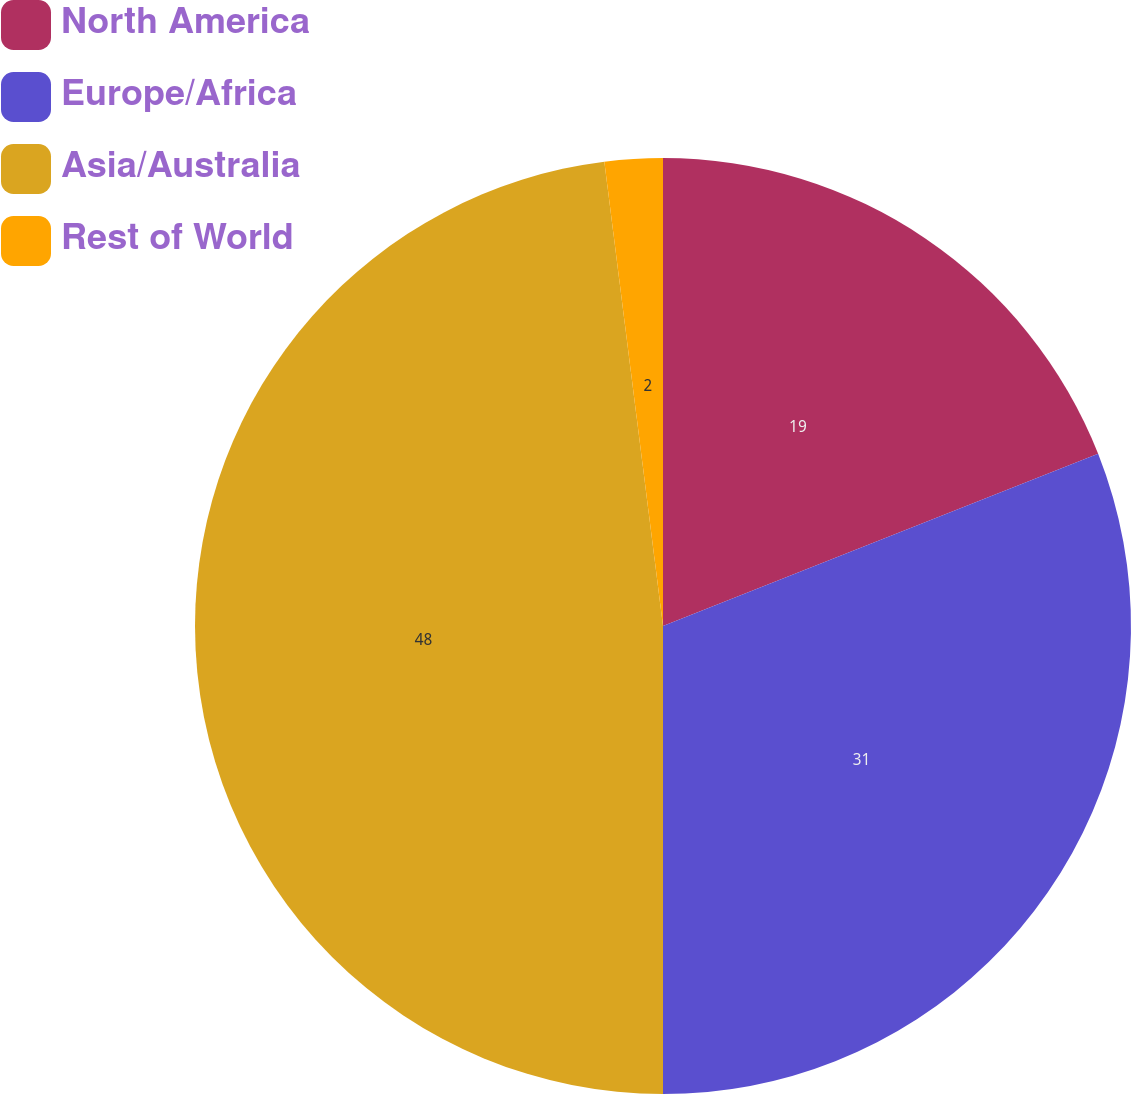Convert chart. <chart><loc_0><loc_0><loc_500><loc_500><pie_chart><fcel>North America<fcel>Europe/Africa<fcel>Asia/Australia<fcel>Rest of World<nl><fcel>19.0%<fcel>31.0%<fcel>48.0%<fcel>2.0%<nl></chart> 